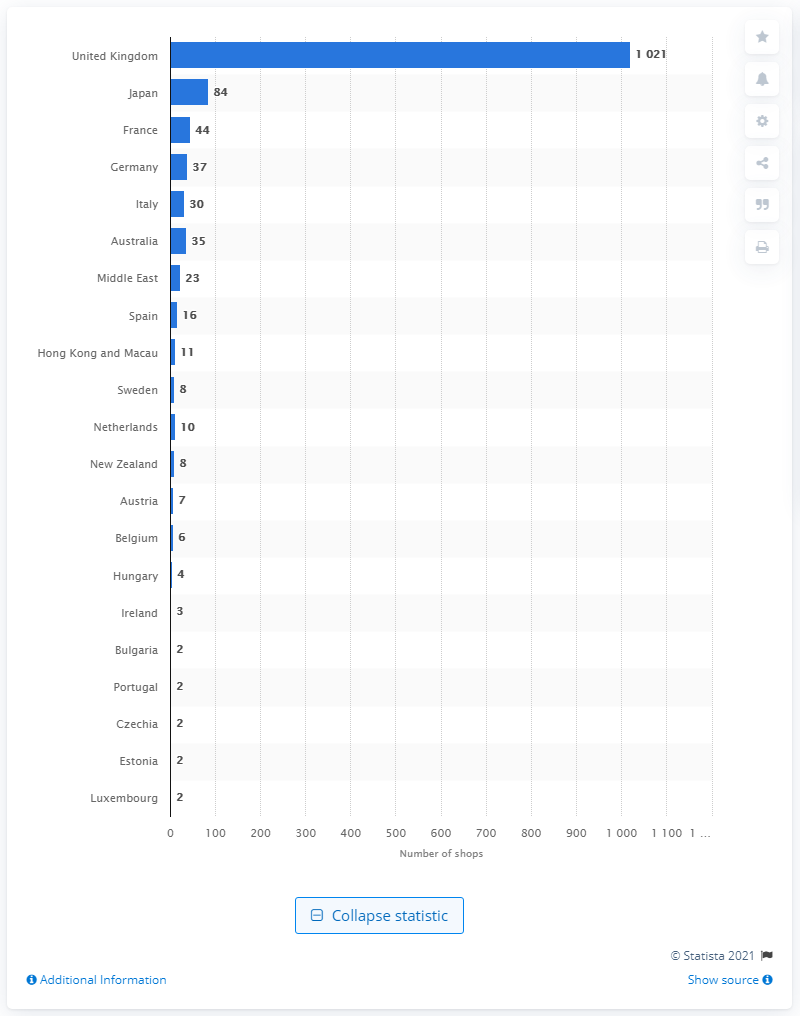Highlight a few significant elements in this photo. As of the present time, there are 84 Lush Cosmetics Limited shops currently operating in Japan. 